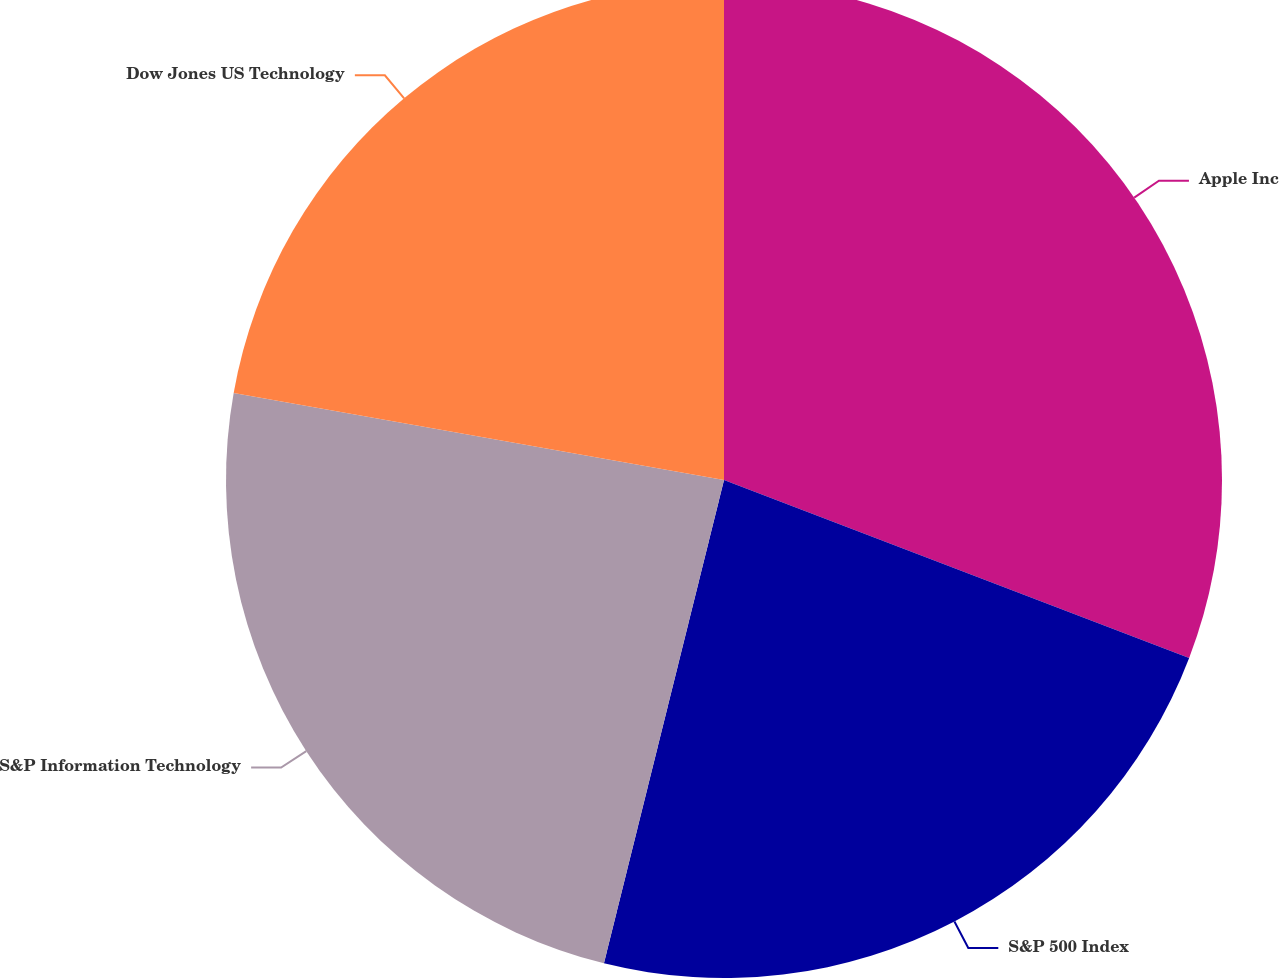Convert chart. <chart><loc_0><loc_0><loc_500><loc_500><pie_chart><fcel>Apple Inc<fcel>S&P 500 Index<fcel>S&P Information Technology<fcel>Dow Jones US Technology<nl><fcel>30.81%<fcel>23.06%<fcel>23.92%<fcel>22.2%<nl></chart> 